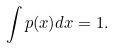Convert formula to latex. <formula><loc_0><loc_0><loc_500><loc_500>\int { p ( x ) d x } = 1 .</formula> 